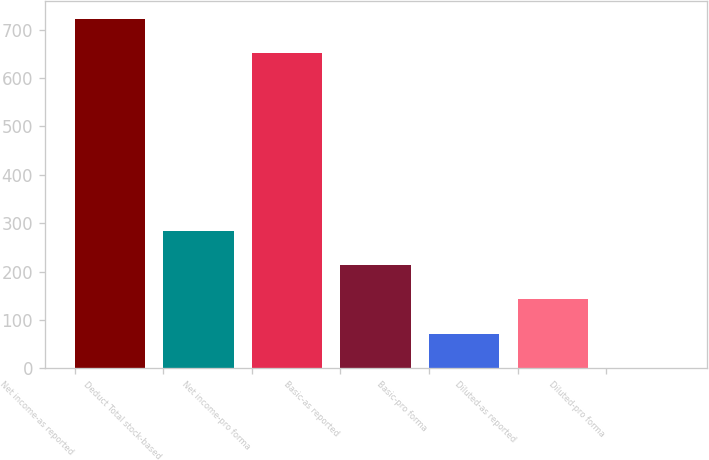<chart> <loc_0><loc_0><loc_500><loc_500><bar_chart><fcel>Net income-as reported<fcel>Deduct Total stock-based<fcel>Net income-pro forma<fcel>Basic-as reported<fcel>Basic-pro forma<fcel>Diluted-as reported<fcel>Diluted-pro forma<nl><fcel>722.57<fcel>283.59<fcel>652<fcel>213.02<fcel>71.88<fcel>142.45<fcel>1.31<nl></chart> 